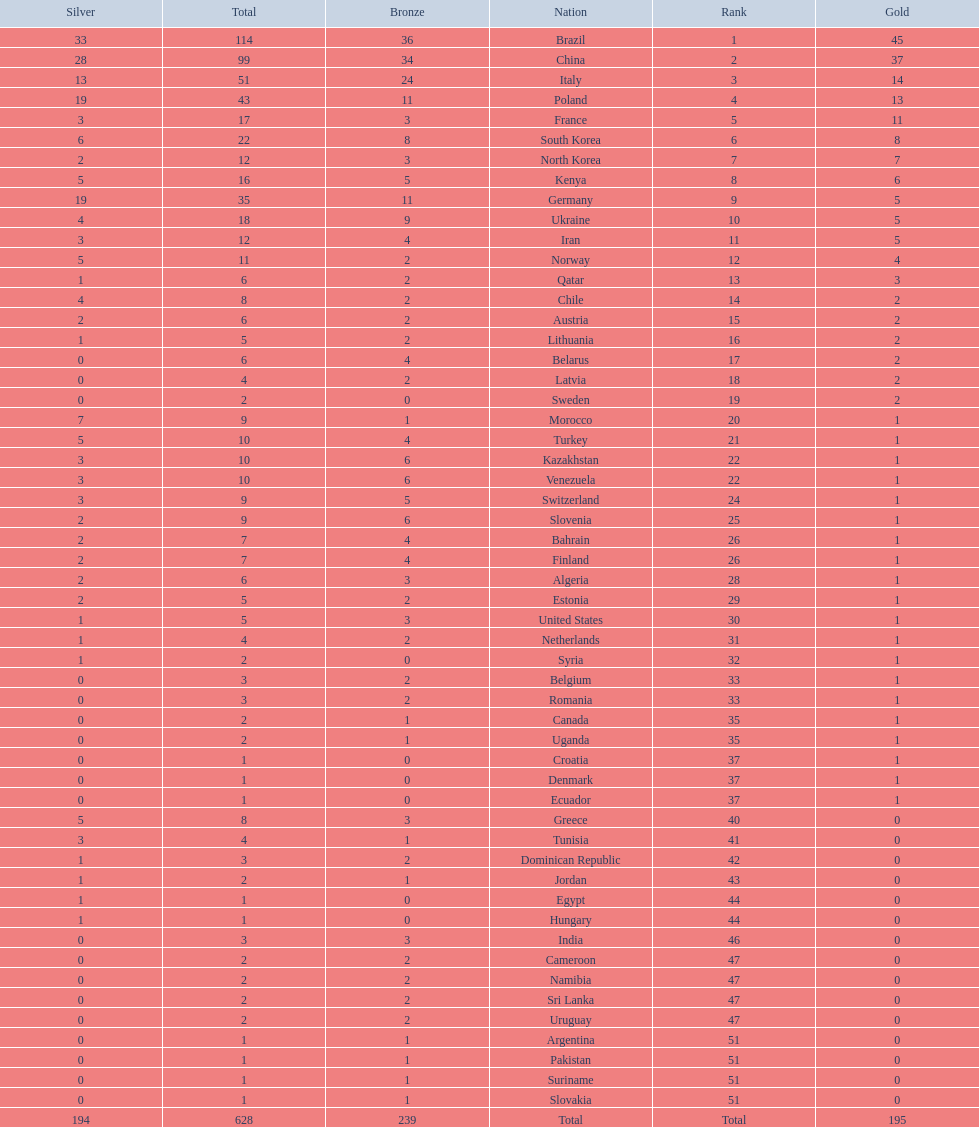Was the total medal count for italy or norway 51? Italy. I'm looking to parse the entire table for insights. Could you assist me with that? {'header': ['Silver', 'Total', 'Bronze', 'Nation', 'Rank', 'Gold'], 'rows': [['33', '114', '36', 'Brazil', '1', '45'], ['28', '99', '34', 'China', '2', '37'], ['13', '51', '24', 'Italy', '3', '14'], ['19', '43', '11', 'Poland', '4', '13'], ['3', '17', '3', 'France', '5', '11'], ['6', '22', '8', 'South Korea', '6', '8'], ['2', '12', '3', 'North Korea', '7', '7'], ['5', '16', '5', 'Kenya', '8', '6'], ['19', '35', '11', 'Germany', '9', '5'], ['4', '18', '9', 'Ukraine', '10', '5'], ['3', '12', '4', 'Iran', '11', '5'], ['5', '11', '2', 'Norway', '12', '4'], ['1', '6', '2', 'Qatar', '13', '3'], ['4', '8', '2', 'Chile', '14', '2'], ['2', '6', '2', 'Austria', '15', '2'], ['1', '5', '2', 'Lithuania', '16', '2'], ['0', '6', '4', 'Belarus', '17', '2'], ['0', '4', '2', 'Latvia', '18', '2'], ['0', '2', '0', 'Sweden', '19', '2'], ['7', '9', '1', 'Morocco', '20', '1'], ['5', '10', '4', 'Turkey', '21', '1'], ['3', '10', '6', 'Kazakhstan', '22', '1'], ['3', '10', '6', 'Venezuela', '22', '1'], ['3', '9', '5', 'Switzerland', '24', '1'], ['2', '9', '6', 'Slovenia', '25', '1'], ['2', '7', '4', 'Bahrain', '26', '1'], ['2', '7', '4', 'Finland', '26', '1'], ['2', '6', '3', 'Algeria', '28', '1'], ['2', '5', '2', 'Estonia', '29', '1'], ['1', '5', '3', 'United States', '30', '1'], ['1', '4', '2', 'Netherlands', '31', '1'], ['1', '2', '0', 'Syria', '32', '1'], ['0', '3', '2', 'Belgium', '33', '1'], ['0', '3', '2', 'Romania', '33', '1'], ['0', '2', '1', 'Canada', '35', '1'], ['0', '2', '1', 'Uganda', '35', '1'], ['0', '1', '0', 'Croatia', '37', '1'], ['0', '1', '0', 'Denmark', '37', '1'], ['0', '1', '0', 'Ecuador', '37', '1'], ['5', '8', '3', 'Greece', '40', '0'], ['3', '4', '1', 'Tunisia', '41', '0'], ['1', '3', '2', 'Dominican Republic', '42', '0'], ['1', '2', '1', 'Jordan', '43', '0'], ['1', '1', '0', 'Egypt', '44', '0'], ['1', '1', '0', 'Hungary', '44', '0'], ['0', '3', '3', 'India', '46', '0'], ['0', '2', '2', 'Cameroon', '47', '0'], ['0', '2', '2', 'Namibia', '47', '0'], ['0', '2', '2', 'Sri Lanka', '47', '0'], ['0', '2', '2', 'Uruguay', '47', '0'], ['0', '1', '1', 'Argentina', '51', '0'], ['0', '1', '1', 'Pakistan', '51', '0'], ['0', '1', '1', 'Suriname', '51', '0'], ['0', '1', '1', 'Slovakia', '51', '0'], ['194', '628', '239', 'Total', 'Total', '195']]} 